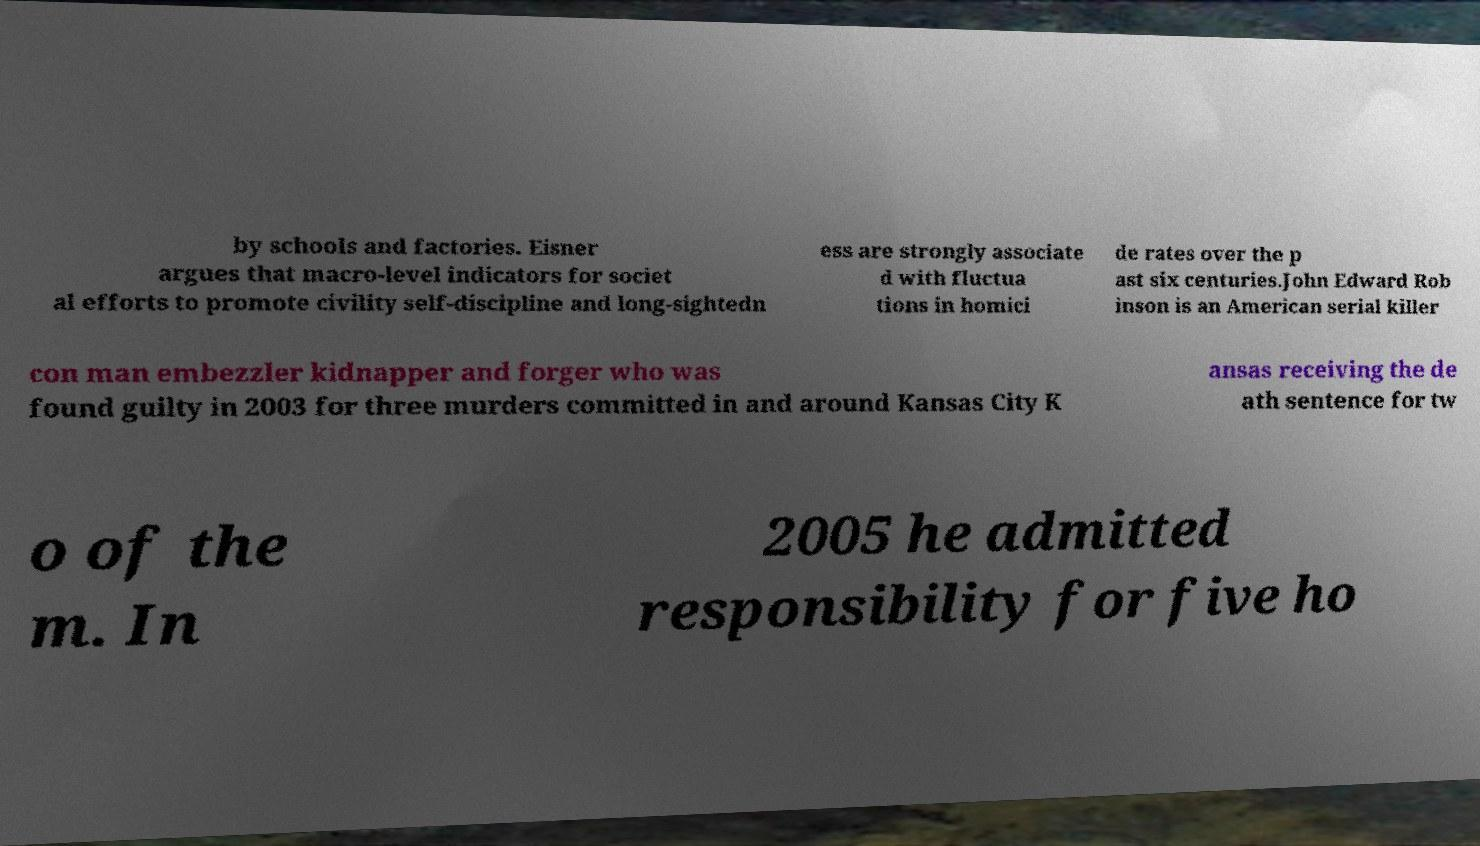There's text embedded in this image that I need extracted. Can you transcribe it verbatim? by schools and factories. Eisner argues that macro-level indicators for societ al efforts to promote civility self-discipline and long-sightedn ess are strongly associate d with fluctua tions in homici de rates over the p ast six centuries.John Edward Rob inson is an American serial killer con man embezzler kidnapper and forger who was found guilty in 2003 for three murders committed in and around Kansas City K ansas receiving the de ath sentence for tw o of the m. In 2005 he admitted responsibility for five ho 